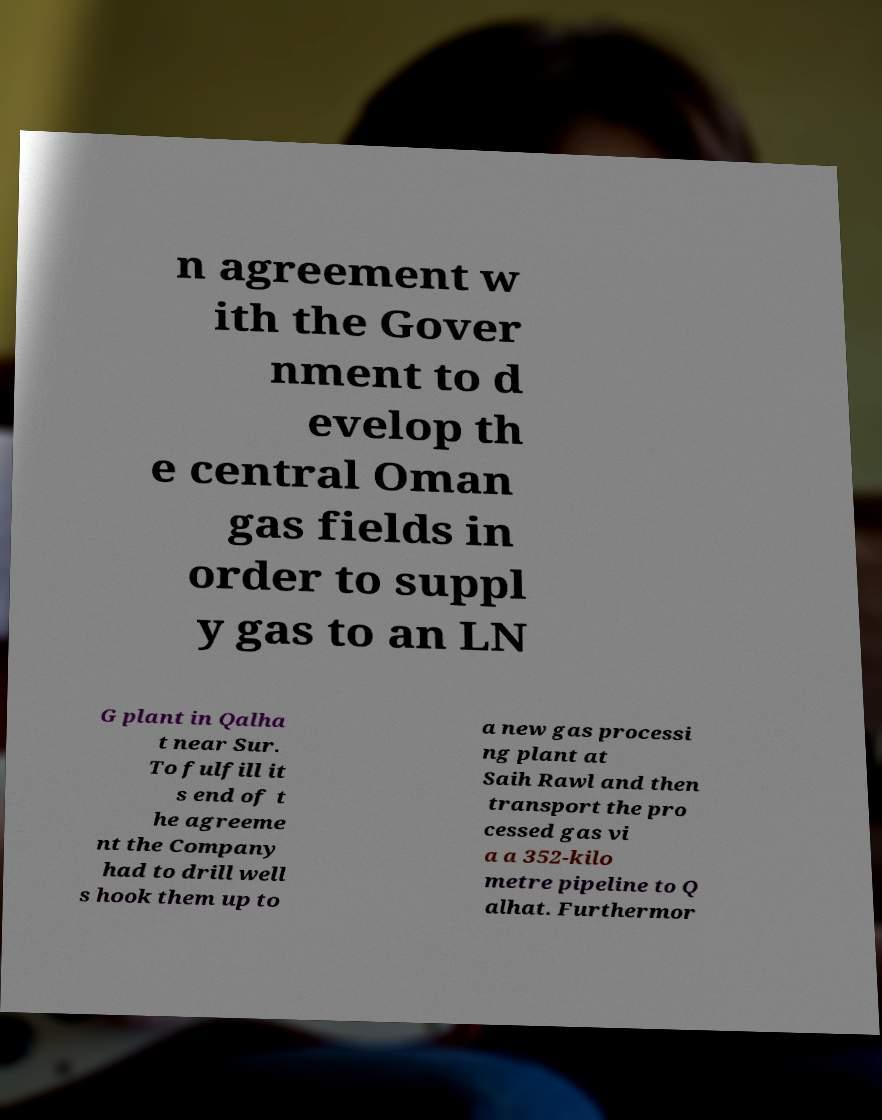Please identify and transcribe the text found in this image. n agreement w ith the Gover nment to d evelop th e central Oman gas fields in order to suppl y gas to an LN G plant in Qalha t near Sur. To fulfill it s end of t he agreeme nt the Company had to drill well s hook them up to a new gas processi ng plant at Saih Rawl and then transport the pro cessed gas vi a a 352-kilo metre pipeline to Q alhat. Furthermor 